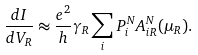Convert formula to latex. <formula><loc_0><loc_0><loc_500><loc_500>\frac { d I } { d V _ { R } } \approx \frac { e ^ { 2 } } { h } \gamma _ { R } \sum _ { i } P ^ { N } _ { i } A _ { i R } ^ { N } ( \mu _ { R } ) .</formula> 